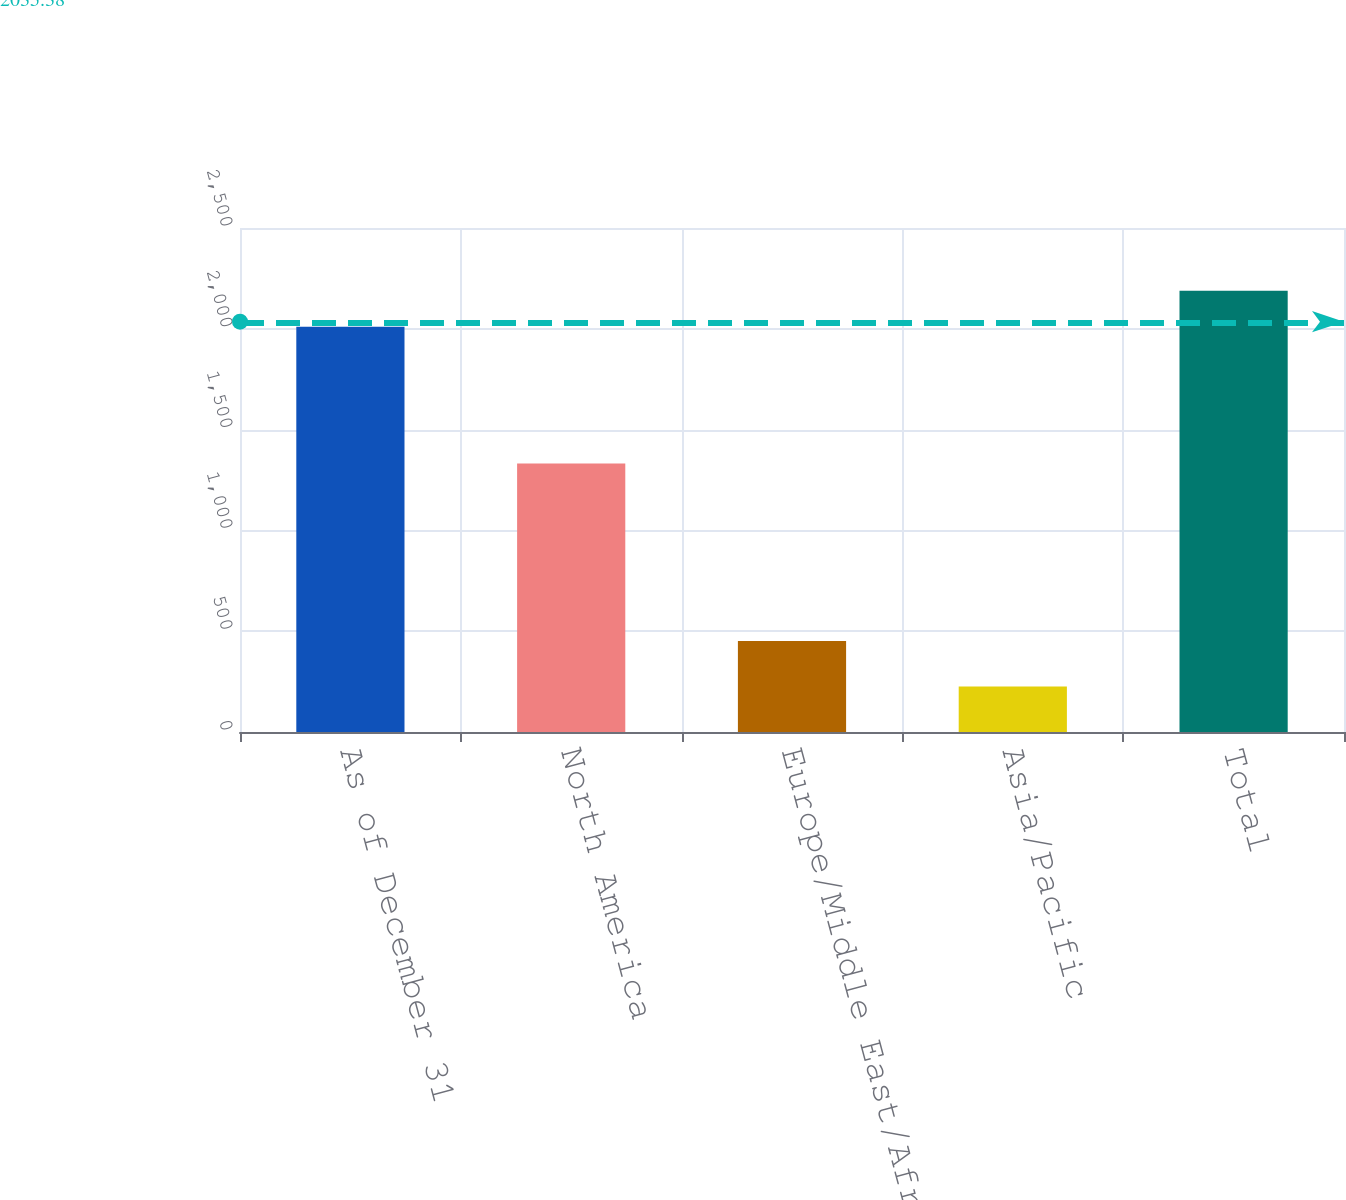<chart> <loc_0><loc_0><loc_500><loc_500><bar_chart><fcel>As of December 31<fcel>North America<fcel>Europe/Middle East/Africa<fcel>Asia/Pacific<fcel>Total<nl><fcel>2010<fcel>1332<fcel>452<fcel>226<fcel>2188.4<nl></chart> 